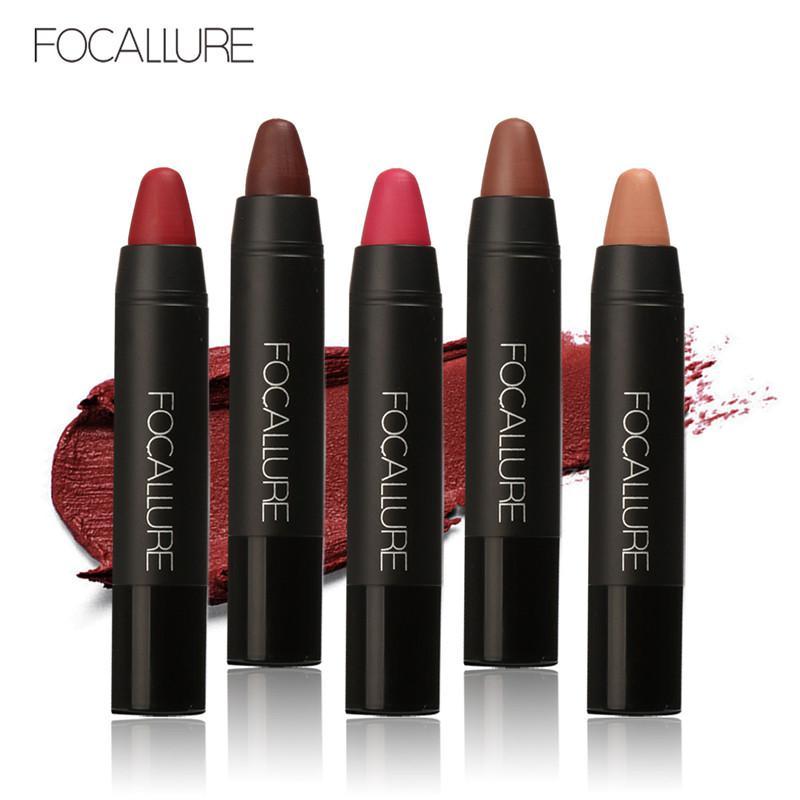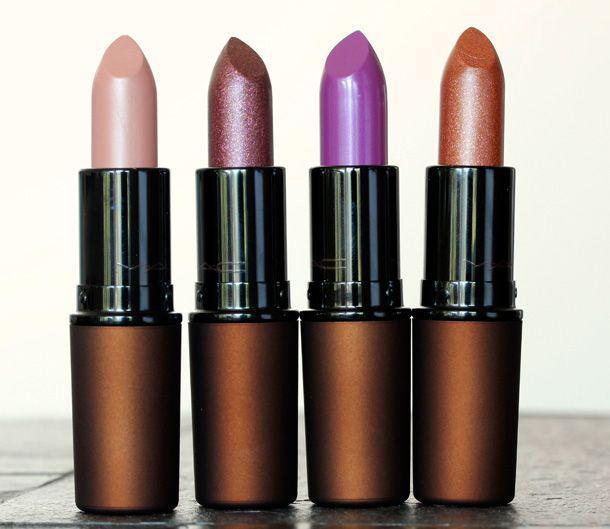The first image is the image on the left, the second image is the image on the right. Given the left and right images, does the statement "The right image includes an odd number of lipsticks standing up with their caps off." hold true? Answer yes or no. No. 